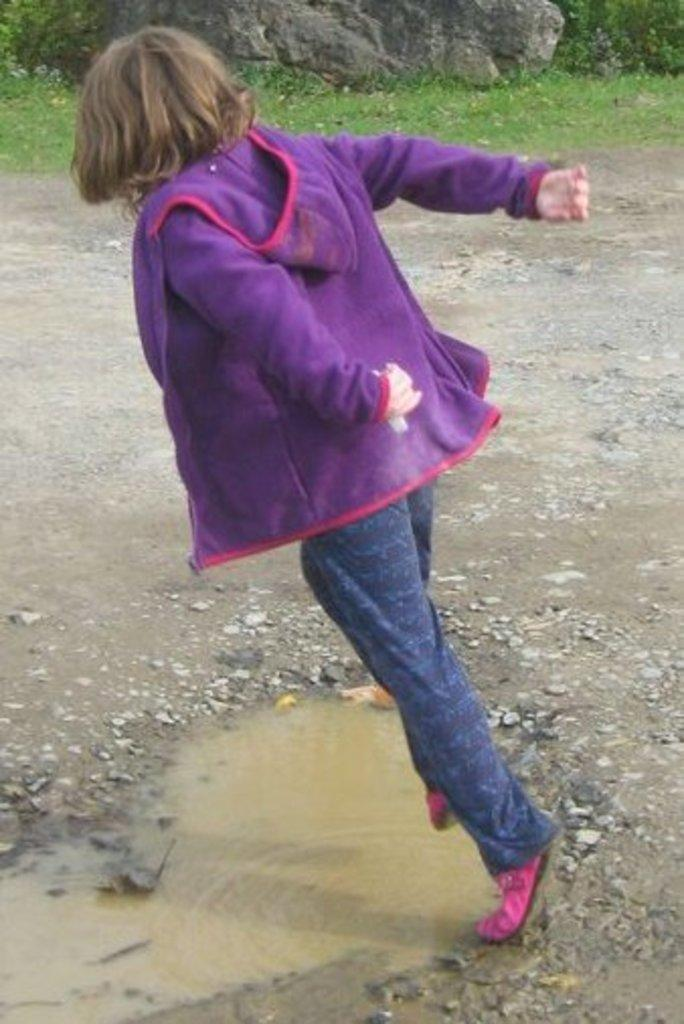What is the main subject of the image? There is a person in the image. Where is the person located in the image? The person is on the ground. What type of terrain is visible in the image? There are stones, grass, and water in the image. What is the largest object in the image? There is a rock in the image. What type of school can be seen in the image? There is no school present in the image. Can you point out the map in the image? There is no map present in the image. 